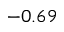<formula> <loc_0><loc_0><loc_500><loc_500>- 0 . 6 9</formula> 